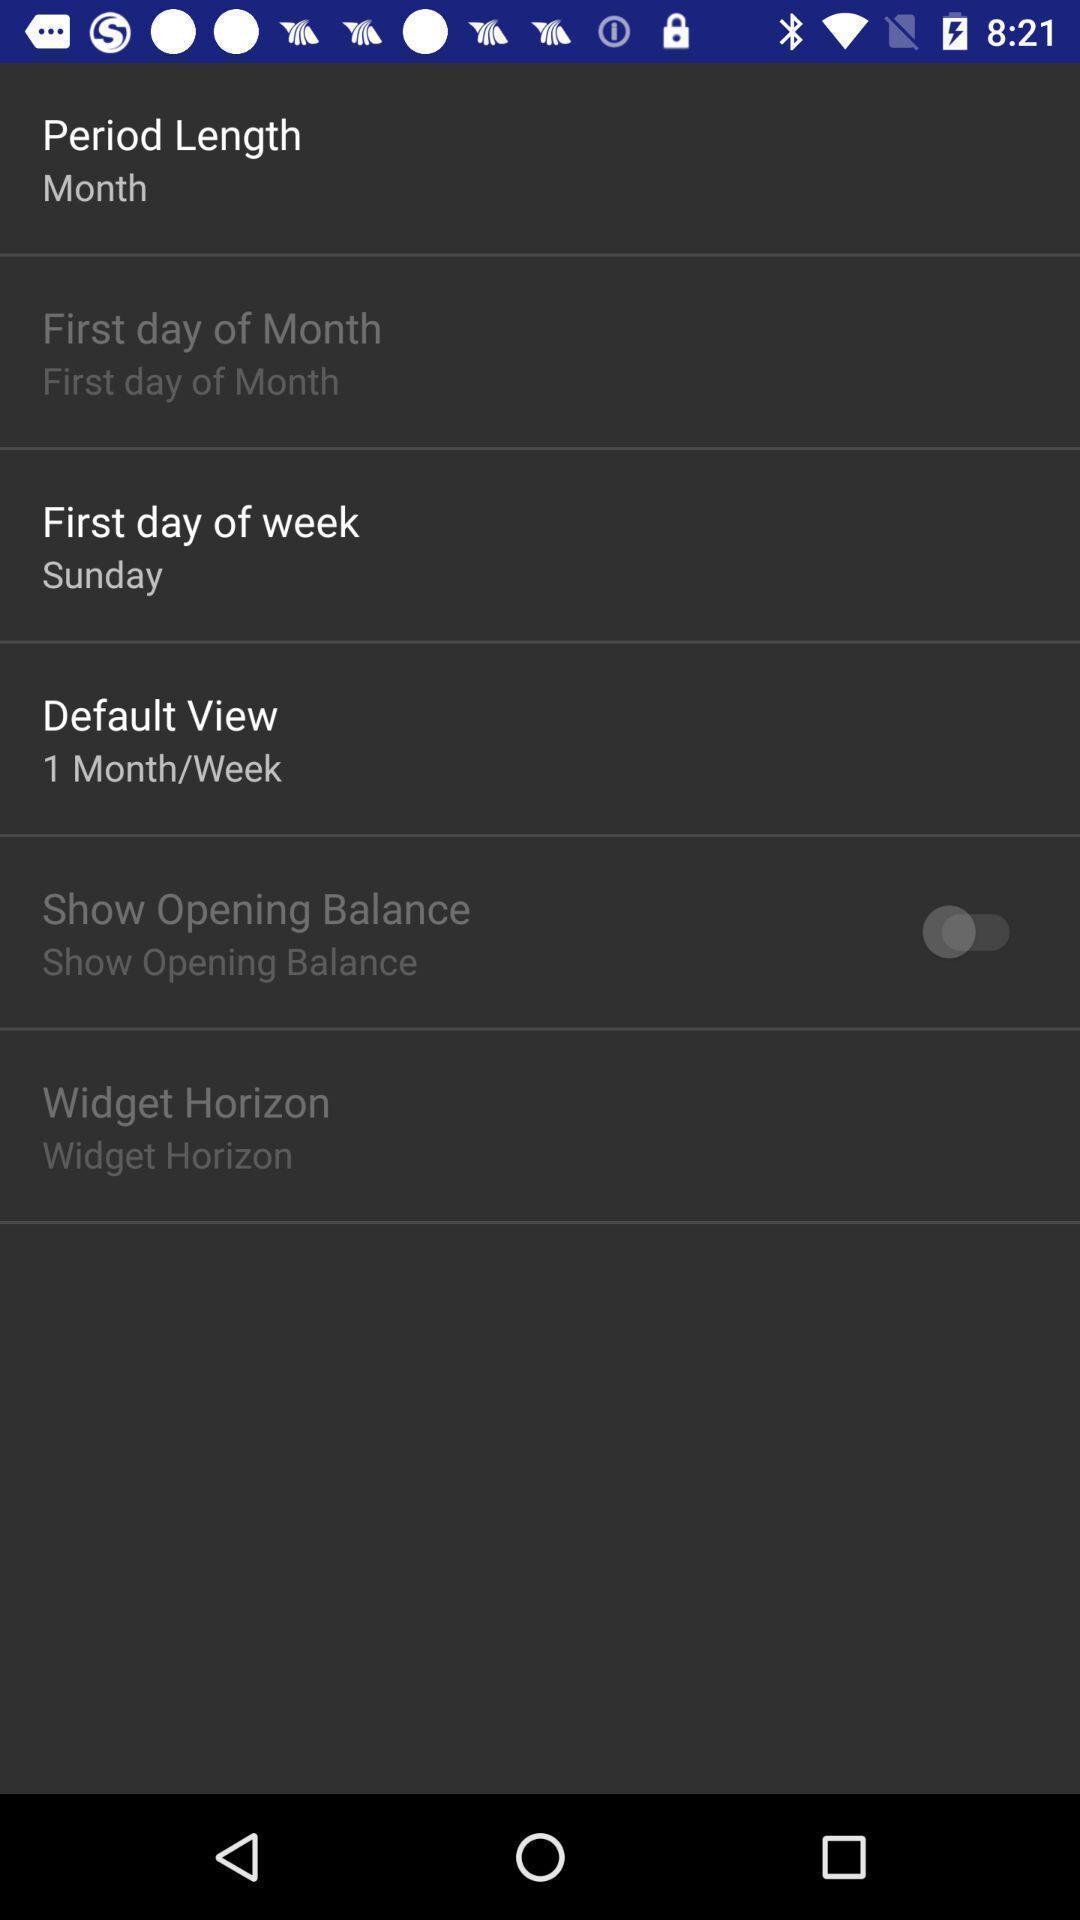Give me a narrative description of this picture. Various settings in the women period application. 